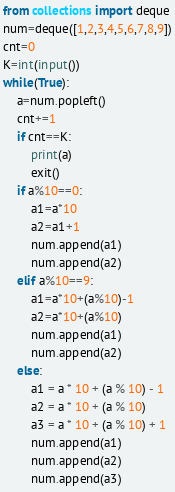<code> <loc_0><loc_0><loc_500><loc_500><_Python_>from collections import deque
num=deque([1,2,3,4,5,6,7,8,9])
cnt=0
K=int(input())
while(True):
    a=num.popleft()
    cnt+=1
    if cnt==K:
        print(a)
        exit()
    if a%10==0:
        a1=a*10
        a2=a1+1
        num.append(a1)
        num.append(a2)
    elif a%10==9:
        a1=a*10+(a%10)-1
        a2=a*10+(a%10)
        num.append(a1)
        num.append(a2)
    else:
        a1 = a * 10 + (a % 10) - 1
        a2 = a * 10 + (a % 10)
        a3 = a * 10 + (a % 10) + 1
        num.append(a1)
        num.append(a2)
        num.append(a3)


</code> 